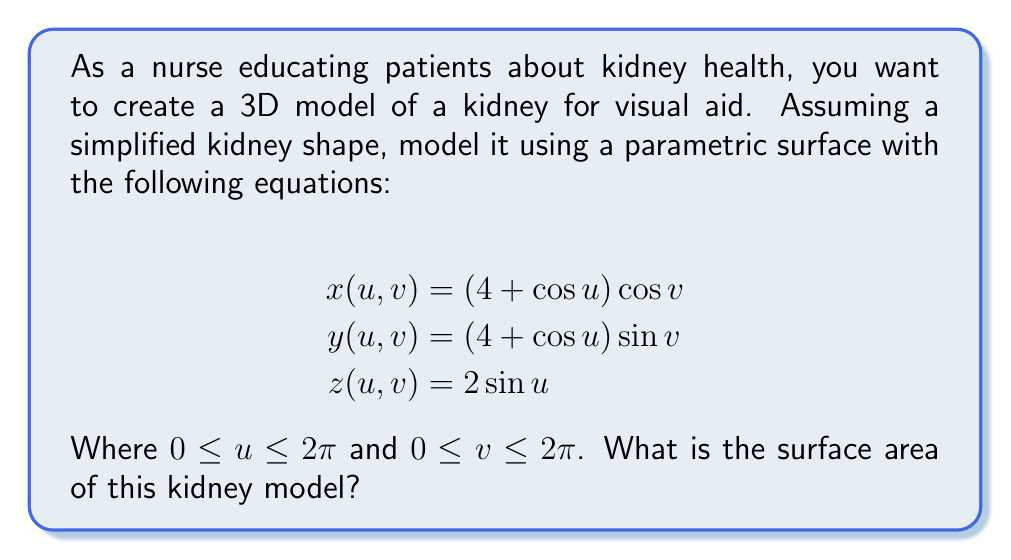Could you help me with this problem? To find the surface area of the parametric surface, we need to follow these steps:

1. Calculate the partial derivatives $\frac{\partial \mathbf{r}}{\partial u}$ and $\frac{\partial \mathbf{r}}{\partial v}$:

   $$\frac{\partial \mathbf{r}}{\partial u} = (-\sin u \cos v, -\sin u \sin v, 2\cos u)$$
   $$\frac{\partial \mathbf{r}}{\partial v} = (-(4 + \cos u)\sin v, (4 + \cos u)\cos v, 0)$$

2. Calculate the cross product $\frac{\partial \mathbf{r}}{\partial u} \times \frac{\partial \mathbf{r}}{\partial v}$:

   $$\frac{\partial \mathbf{r}}{\partial u} \times \frac{\partial \mathbf{r}}{\partial v} = (2(4 + \cos u)\cos u, 2(4 + \cos u)\sin u, (4 + \cos u)\sin u)$$

3. Calculate the magnitude of the cross product:

   $$\left|\frac{\partial \mathbf{r}}{\partial u} \times \frac{\partial \mathbf{r}}{\partial v}\right| = \sqrt{4(4 + \cos u)^2 + (4 + \cos u)^2\sin^2 u}$$
   $$= (4 + \cos u)\sqrt{4 + \sin^2 u}$$

4. Set up the surface area integral:

   $$A = \int_0^{2\pi} \int_0^{2\pi} \left|\frac{\partial \mathbf{r}}{\partial u} \times \frac{\partial \mathbf{r}}{\partial v}\right| du dv$$

5. Substitute the magnitude of the cross product:

   $$A = \int_0^{2\pi} \int_0^{2\pi} (4 + \cos u)\sqrt{4 + \sin^2 u} \, du dv$$

6. Evaluate the inner integral with respect to $v$:

   $$A = 2\pi \int_0^{2\pi} (4 + \cos u)\sqrt{4 + \sin^2 u} \, du$$

7. This integral doesn't have a closed-form solution, so we need to use numerical integration methods to approximate the result. Using a numerical integration tool or computer algebra system, we find:

   $$A \approx 175.9184$$

Therefore, the surface area of the kidney model is approximately 175.9184 square units.
Answer: 175.9184 square units 